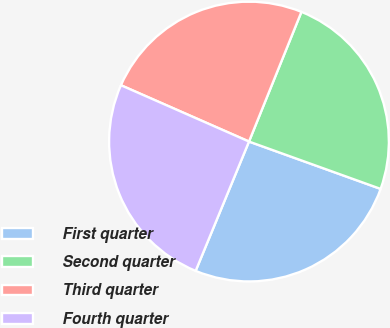Convert chart to OTSL. <chart><loc_0><loc_0><loc_500><loc_500><pie_chart><fcel>First quarter<fcel>Second quarter<fcel>Third quarter<fcel>Fourth quarter<nl><fcel>25.73%<fcel>24.38%<fcel>24.52%<fcel>25.37%<nl></chart> 